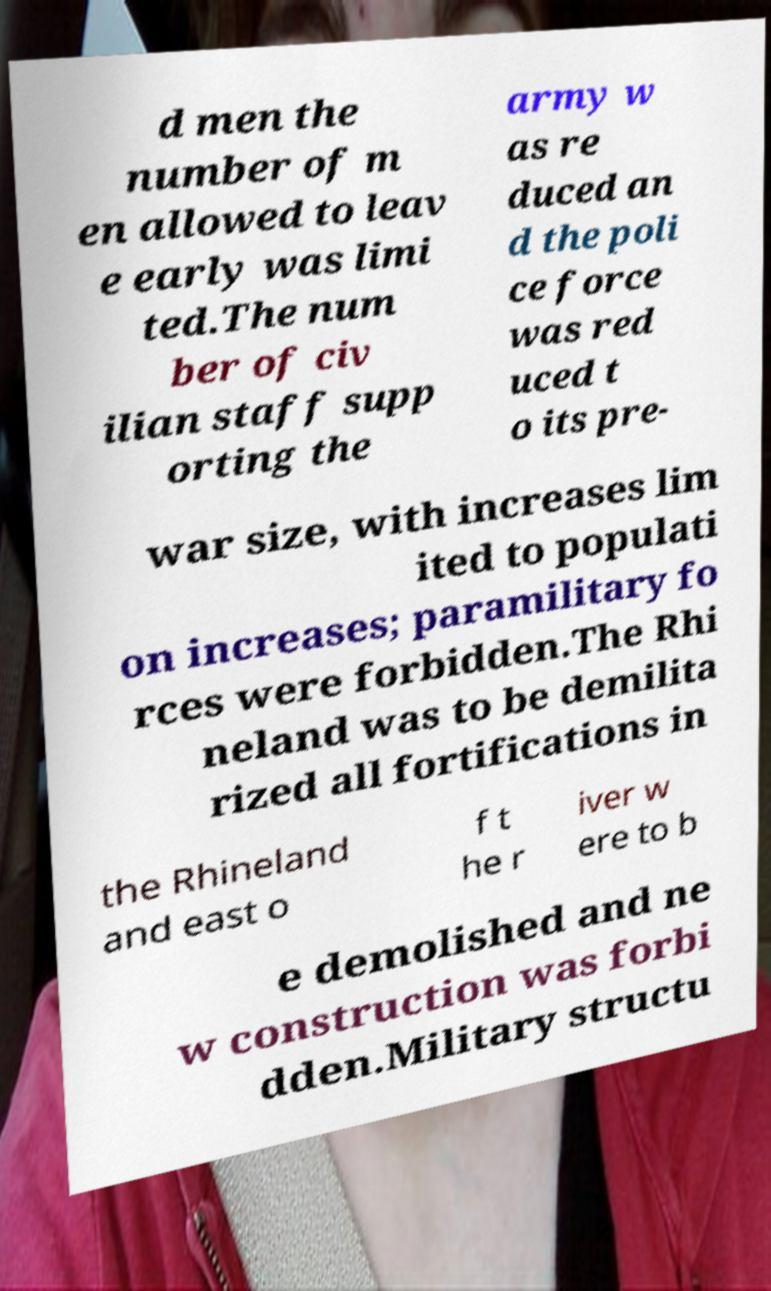There's text embedded in this image that I need extracted. Can you transcribe it verbatim? d men the number of m en allowed to leav e early was limi ted.The num ber of civ ilian staff supp orting the army w as re duced an d the poli ce force was red uced t o its pre- war size, with increases lim ited to populati on increases; paramilitary fo rces were forbidden.The Rhi neland was to be demilita rized all fortifications in the Rhineland and east o f t he r iver w ere to b e demolished and ne w construction was forbi dden.Military structu 